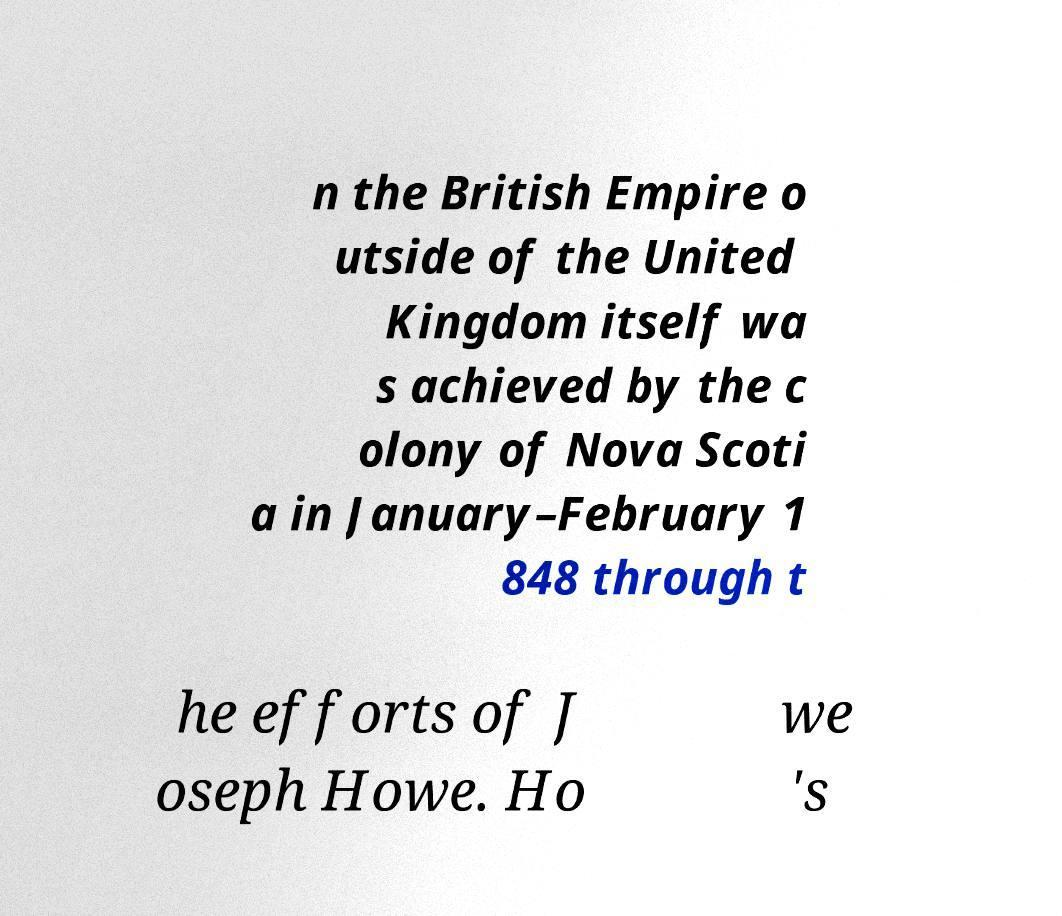Can you accurately transcribe the text from the provided image for me? n the British Empire o utside of the United Kingdom itself wa s achieved by the c olony of Nova Scoti a in January–February 1 848 through t he efforts of J oseph Howe. Ho we 's 